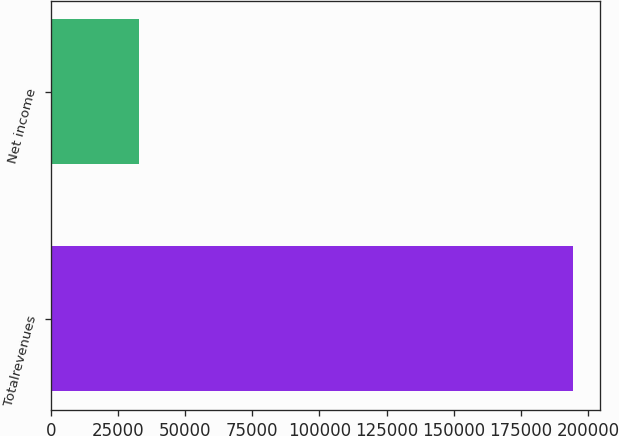<chart> <loc_0><loc_0><loc_500><loc_500><bar_chart><fcel>Totalrevenues<fcel>Net income<nl><fcel>194578<fcel>32686<nl></chart> 